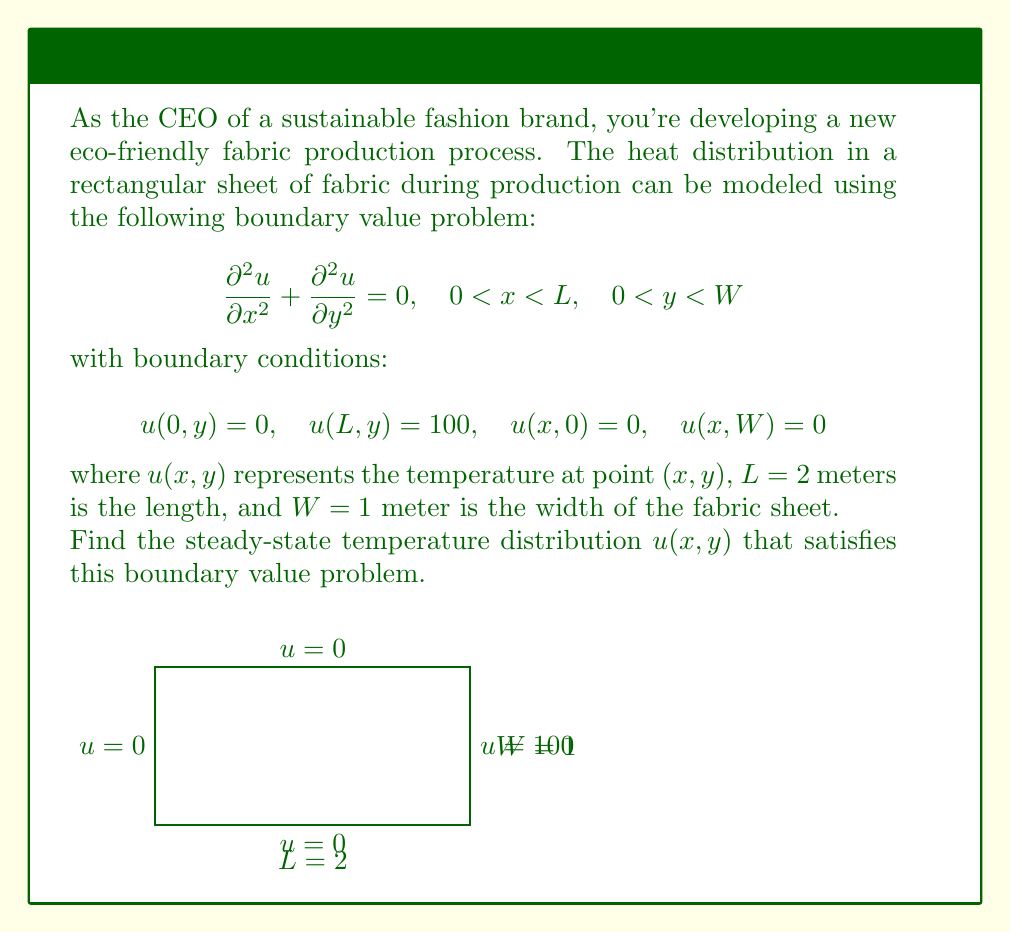Solve this math problem. To solve this boundary value problem, we'll use the method of separation of variables:

1) Assume the solution has the form $u(x,y) = X(x)Y(y)$.

2) Substituting into the PDE:
   $$X''(x)Y(y) + X(x)Y''(y) = 0$$
   $$\frac{X''(x)}{X(x)} = -\frac{Y''(y)}{Y(y)} = -\lambda^2$$

3) This gives us two ODEs:
   $$X''(x) + \lambda^2 X(x) = 0$$
   $$Y''(y) - \lambda^2 Y(y) = 0$$

4) The general solutions are:
   $$X(x) = A \sin(\lambda x) + B \cos(\lambda x)$$
   $$Y(y) = C \sinh(\lambda y) + D \cosh(\lambda y)$$

5) Applying the boundary conditions:
   - $u(0,y) = 0$ implies $B = 0$
   - $u(x,0) = u(x,W) = 0$ implies $Y(y) = C \sinh(\lambda y)$ and $\lambda = \frac{n\pi}{W} = n\pi$ (since $W=1$)

6) The solution takes the form:
   $$u(x,y) = \sum_{n=1}^{\infty} A_n \sin(n\pi x) \sinh(n\pi y)$$

7) Apply the final boundary condition $u(L,y) = 100$:
   $$100 = \sum_{n=1}^{\infty} A_n \sin(2n\pi) \sinh(n\pi y)$$

8) Since $\sin(2n\pi) = 0$ for all $n$, this condition can't be satisfied. We need to modify our solution:
   $$u(x,y) = 50x + \sum_{n=1}^{\infty} A_n \sin(\frac{n\pi x}{2}) \sinh(n\pi y)$$

9) Now, $u(L,y) = 100$ is satisfied, and we need to determine $A_n$:
   $$-50x = \sum_{n=1}^{\infty} A_n \sin(\frac{n\pi x}{2}) \sinh(n\pi y)$$

10) Using the orthogonality of sine functions:
    $$A_n = -\frac{400}{n\pi \sinh(n\pi)} \quad \text{for odd } n, \quad A_n = 0 \quad \text{for even } n$$

Therefore, the final solution is:
$$u(x,y) = 50x - \sum_{n=1,3,5,...}^{\infty} \frac{400}{n\pi \sinh(n\pi)} \sin(\frac{n\pi x}{2}) \sinh(n\pi y)$$
Answer: $$u(x,y) = 50x - \sum_{n=1,3,5,...}^{\infty} \frac{400}{n\pi \sinh(n\pi)} \sin(\frac{n\pi x}{2}) \sinh(n\pi y)$$ 